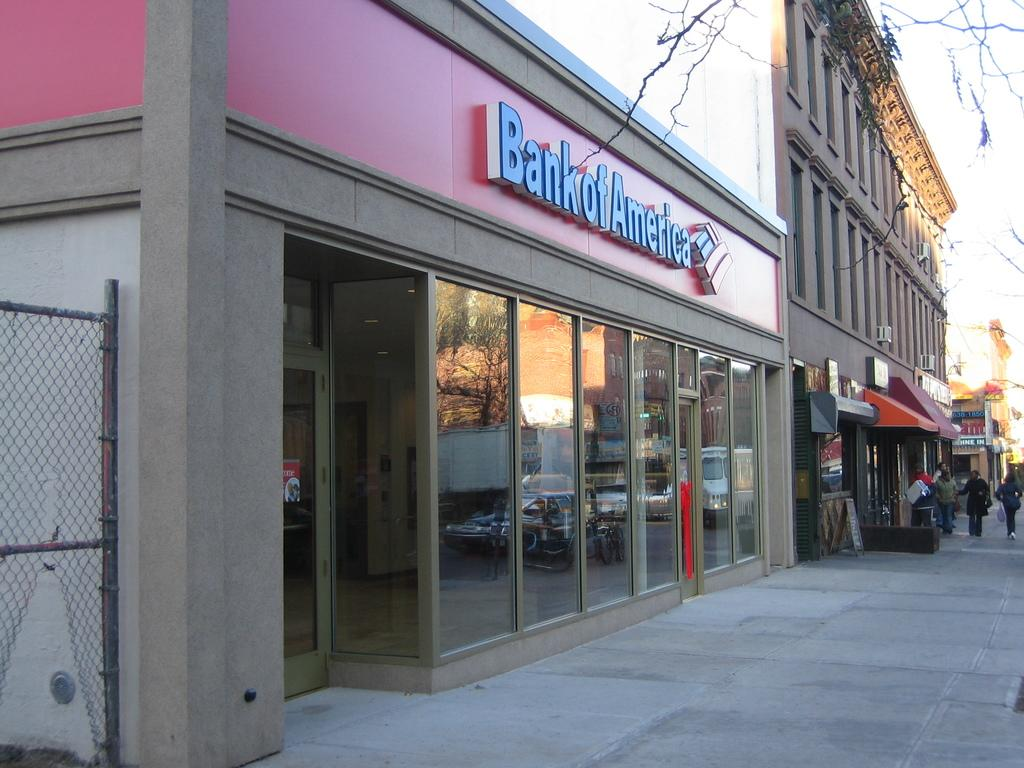<image>
Present a compact description of the photo's key features. the outside of a building that has a sign above the doors that says 'bank of america' 